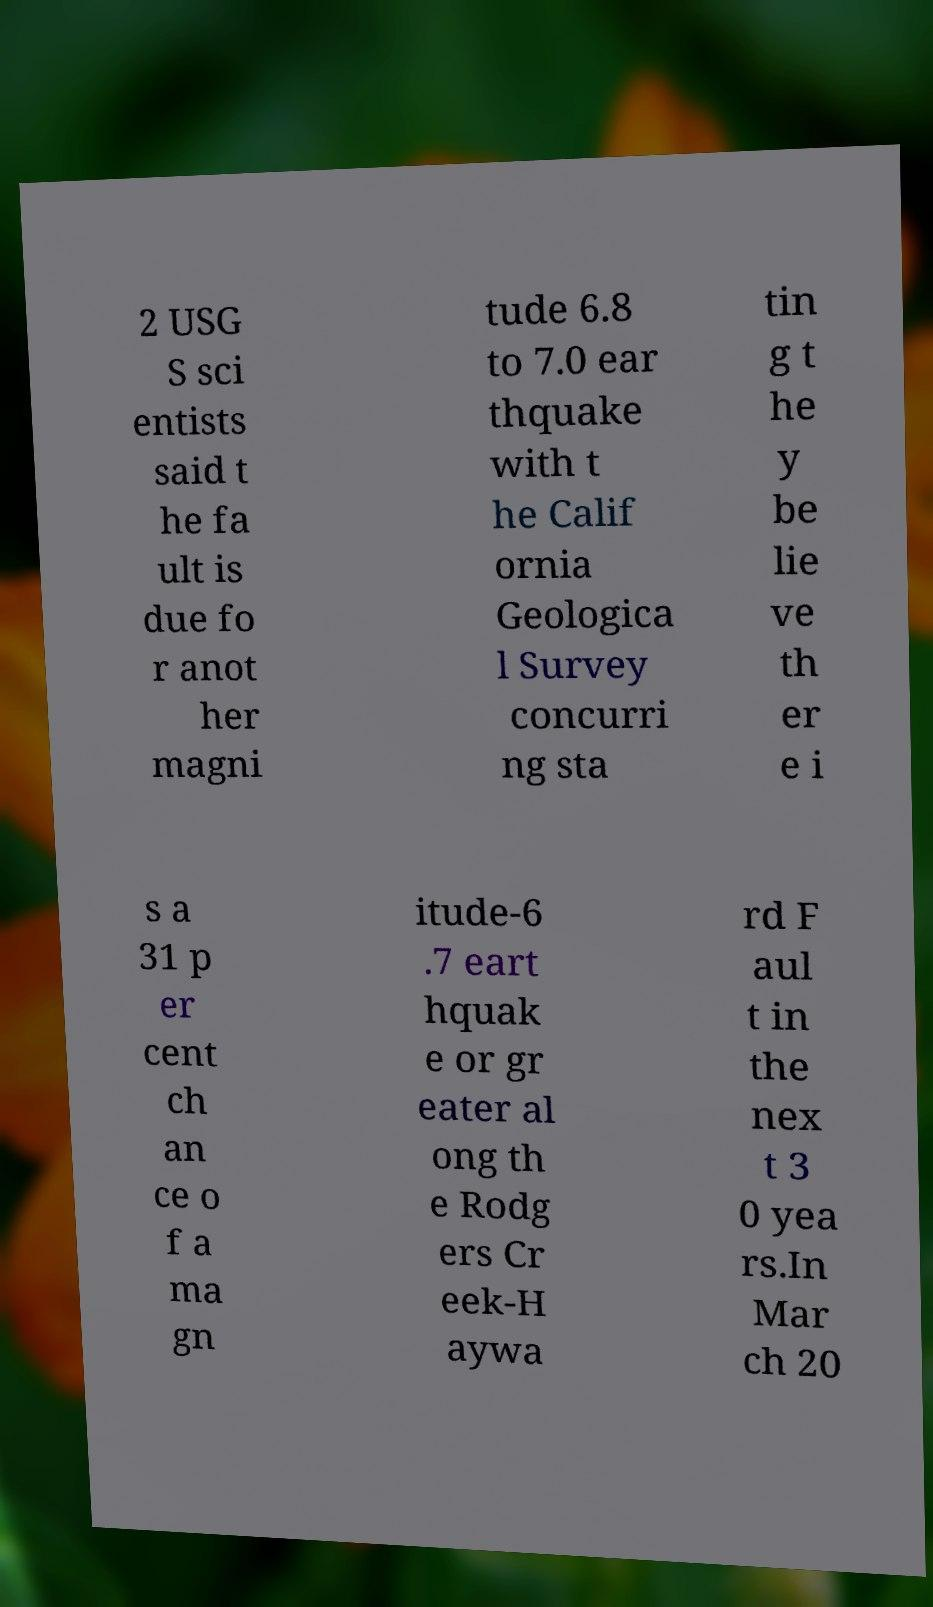Can you accurately transcribe the text from the provided image for me? 2 USG S sci entists said t he fa ult is due fo r anot her magni tude 6.8 to 7.0 ear thquake with t he Calif ornia Geologica l Survey concurri ng sta tin g t he y be lie ve th er e i s a 31 p er cent ch an ce o f a ma gn itude-6 .7 eart hquak e or gr eater al ong th e Rodg ers Cr eek-H aywa rd F aul t in the nex t 3 0 yea rs.In Mar ch 20 